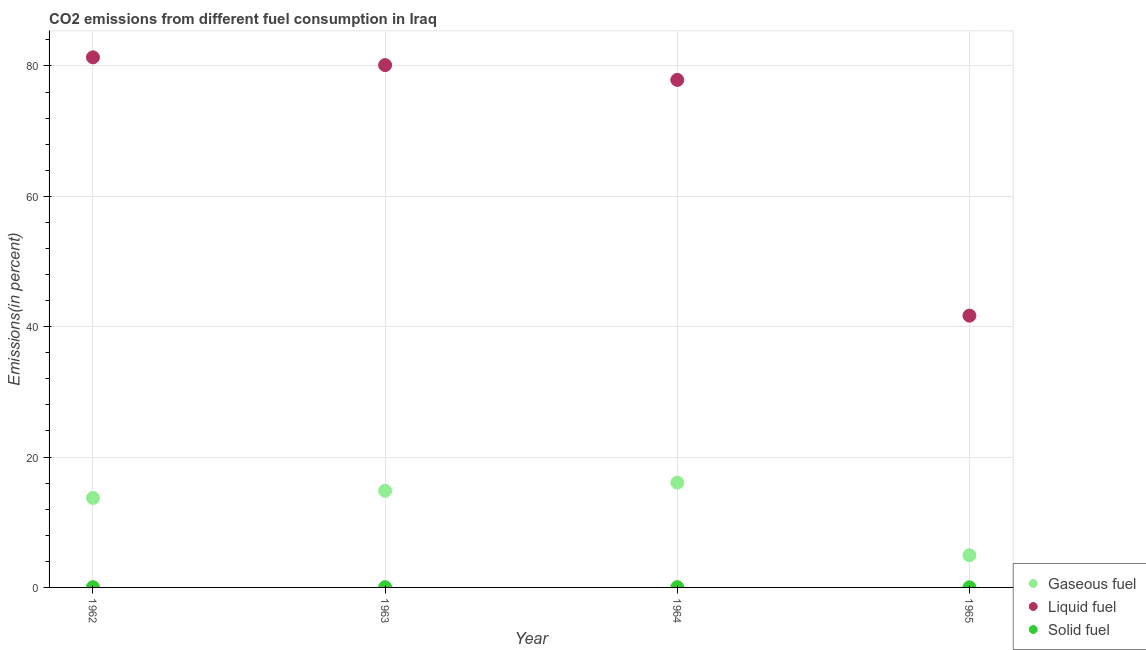How many different coloured dotlines are there?
Offer a very short reply. 3. Is the number of dotlines equal to the number of legend labels?
Make the answer very short. Yes. What is the percentage of solid fuel emission in 1962?
Make the answer very short. 0.04. Across all years, what is the maximum percentage of gaseous fuel emission?
Give a very brief answer. 16.08. Across all years, what is the minimum percentage of gaseous fuel emission?
Give a very brief answer. 4.94. In which year was the percentage of gaseous fuel emission maximum?
Your response must be concise. 1964. In which year was the percentage of liquid fuel emission minimum?
Offer a terse response. 1965. What is the total percentage of gaseous fuel emission in the graph?
Keep it short and to the point. 49.57. What is the difference between the percentage of liquid fuel emission in 1962 and that in 1965?
Your answer should be very brief. 39.63. What is the difference between the percentage of liquid fuel emission in 1963 and the percentage of gaseous fuel emission in 1962?
Give a very brief answer. 66.41. What is the average percentage of gaseous fuel emission per year?
Your answer should be very brief. 12.39. In the year 1964, what is the difference between the percentage of solid fuel emission and percentage of gaseous fuel emission?
Your answer should be very brief. -16.04. In how many years, is the percentage of solid fuel emission greater than 60 %?
Make the answer very short. 0. What is the ratio of the percentage of solid fuel emission in 1962 to that in 1963?
Provide a succinct answer. 1.04. Is the difference between the percentage of gaseous fuel emission in 1962 and 1963 greater than the difference between the percentage of solid fuel emission in 1962 and 1963?
Your answer should be compact. No. What is the difference between the highest and the second highest percentage of liquid fuel emission?
Give a very brief answer. 1.19. What is the difference between the highest and the lowest percentage of liquid fuel emission?
Offer a very short reply. 39.63. In how many years, is the percentage of gaseous fuel emission greater than the average percentage of gaseous fuel emission taken over all years?
Make the answer very short. 3. Is it the case that in every year, the sum of the percentage of gaseous fuel emission and percentage of liquid fuel emission is greater than the percentage of solid fuel emission?
Make the answer very short. Yes. Does the percentage of gaseous fuel emission monotonically increase over the years?
Offer a terse response. No. Is the percentage of solid fuel emission strictly greater than the percentage of liquid fuel emission over the years?
Make the answer very short. No. How many dotlines are there?
Provide a short and direct response. 3. How many years are there in the graph?
Make the answer very short. 4. Does the graph contain grids?
Offer a very short reply. Yes. Where does the legend appear in the graph?
Make the answer very short. Bottom right. How many legend labels are there?
Keep it short and to the point. 3. How are the legend labels stacked?
Offer a very short reply. Vertical. What is the title of the graph?
Provide a short and direct response. CO2 emissions from different fuel consumption in Iraq. Does "Transport equipments" appear as one of the legend labels in the graph?
Provide a short and direct response. No. What is the label or title of the X-axis?
Offer a terse response. Year. What is the label or title of the Y-axis?
Keep it short and to the point. Emissions(in percent). What is the Emissions(in percent) in Gaseous fuel in 1962?
Keep it short and to the point. 13.72. What is the Emissions(in percent) in Liquid fuel in 1962?
Your answer should be very brief. 81.32. What is the Emissions(in percent) in Solid fuel in 1962?
Make the answer very short. 0.04. What is the Emissions(in percent) of Gaseous fuel in 1963?
Offer a terse response. 14.83. What is the Emissions(in percent) of Liquid fuel in 1963?
Your answer should be very brief. 80.13. What is the Emissions(in percent) of Solid fuel in 1963?
Provide a succinct answer. 0.04. What is the Emissions(in percent) in Gaseous fuel in 1964?
Make the answer very short. 16.08. What is the Emissions(in percent) of Liquid fuel in 1964?
Offer a terse response. 77.86. What is the Emissions(in percent) in Solid fuel in 1964?
Your answer should be very brief. 0.04. What is the Emissions(in percent) in Gaseous fuel in 1965?
Your answer should be very brief. 4.94. What is the Emissions(in percent) in Liquid fuel in 1965?
Offer a very short reply. 41.69. What is the Emissions(in percent) of Solid fuel in 1965?
Your answer should be compact. 0.02. Across all years, what is the maximum Emissions(in percent) of Gaseous fuel?
Provide a short and direct response. 16.08. Across all years, what is the maximum Emissions(in percent) in Liquid fuel?
Your response must be concise. 81.32. Across all years, what is the maximum Emissions(in percent) in Solid fuel?
Keep it short and to the point. 0.04. Across all years, what is the minimum Emissions(in percent) of Gaseous fuel?
Make the answer very short. 4.94. Across all years, what is the minimum Emissions(in percent) in Liquid fuel?
Your answer should be very brief. 41.69. Across all years, what is the minimum Emissions(in percent) of Solid fuel?
Offer a terse response. 0.02. What is the total Emissions(in percent) of Gaseous fuel in the graph?
Make the answer very short. 49.57. What is the total Emissions(in percent) of Liquid fuel in the graph?
Offer a very short reply. 281.01. What is the total Emissions(in percent) of Solid fuel in the graph?
Your answer should be compact. 0.14. What is the difference between the Emissions(in percent) of Gaseous fuel in 1962 and that in 1963?
Make the answer very short. -1.11. What is the difference between the Emissions(in percent) of Liquid fuel in 1962 and that in 1963?
Provide a short and direct response. 1.19. What is the difference between the Emissions(in percent) in Solid fuel in 1962 and that in 1963?
Provide a short and direct response. 0. What is the difference between the Emissions(in percent) of Gaseous fuel in 1962 and that in 1964?
Give a very brief answer. -2.36. What is the difference between the Emissions(in percent) in Liquid fuel in 1962 and that in 1964?
Make the answer very short. 3.46. What is the difference between the Emissions(in percent) of Gaseous fuel in 1962 and that in 1965?
Your answer should be compact. 8.79. What is the difference between the Emissions(in percent) of Liquid fuel in 1962 and that in 1965?
Keep it short and to the point. 39.63. What is the difference between the Emissions(in percent) of Solid fuel in 1962 and that in 1965?
Give a very brief answer. 0.02. What is the difference between the Emissions(in percent) in Gaseous fuel in 1963 and that in 1964?
Your response must be concise. -1.25. What is the difference between the Emissions(in percent) of Liquid fuel in 1963 and that in 1964?
Make the answer very short. 2.27. What is the difference between the Emissions(in percent) in Solid fuel in 1963 and that in 1964?
Offer a terse response. -0. What is the difference between the Emissions(in percent) of Gaseous fuel in 1963 and that in 1965?
Make the answer very short. 9.9. What is the difference between the Emissions(in percent) of Liquid fuel in 1963 and that in 1965?
Make the answer very short. 38.44. What is the difference between the Emissions(in percent) of Solid fuel in 1963 and that in 1965?
Your response must be concise. 0.02. What is the difference between the Emissions(in percent) in Gaseous fuel in 1964 and that in 1965?
Offer a very short reply. 11.14. What is the difference between the Emissions(in percent) of Liquid fuel in 1964 and that in 1965?
Offer a terse response. 36.16. What is the difference between the Emissions(in percent) in Solid fuel in 1964 and that in 1965?
Provide a short and direct response. 0.02. What is the difference between the Emissions(in percent) in Gaseous fuel in 1962 and the Emissions(in percent) in Liquid fuel in 1963?
Your response must be concise. -66.41. What is the difference between the Emissions(in percent) of Gaseous fuel in 1962 and the Emissions(in percent) of Solid fuel in 1963?
Your answer should be very brief. 13.68. What is the difference between the Emissions(in percent) of Liquid fuel in 1962 and the Emissions(in percent) of Solid fuel in 1963?
Make the answer very short. 81.28. What is the difference between the Emissions(in percent) of Gaseous fuel in 1962 and the Emissions(in percent) of Liquid fuel in 1964?
Your answer should be very brief. -64.14. What is the difference between the Emissions(in percent) in Gaseous fuel in 1962 and the Emissions(in percent) in Solid fuel in 1964?
Keep it short and to the point. 13.68. What is the difference between the Emissions(in percent) in Liquid fuel in 1962 and the Emissions(in percent) in Solid fuel in 1964?
Provide a short and direct response. 81.28. What is the difference between the Emissions(in percent) in Gaseous fuel in 1962 and the Emissions(in percent) in Liquid fuel in 1965?
Your answer should be very brief. -27.97. What is the difference between the Emissions(in percent) of Gaseous fuel in 1962 and the Emissions(in percent) of Solid fuel in 1965?
Your answer should be compact. 13.7. What is the difference between the Emissions(in percent) in Liquid fuel in 1962 and the Emissions(in percent) in Solid fuel in 1965?
Keep it short and to the point. 81.3. What is the difference between the Emissions(in percent) in Gaseous fuel in 1963 and the Emissions(in percent) in Liquid fuel in 1964?
Offer a very short reply. -63.03. What is the difference between the Emissions(in percent) of Gaseous fuel in 1963 and the Emissions(in percent) of Solid fuel in 1964?
Your response must be concise. 14.79. What is the difference between the Emissions(in percent) in Liquid fuel in 1963 and the Emissions(in percent) in Solid fuel in 1964?
Your response must be concise. 80.09. What is the difference between the Emissions(in percent) of Gaseous fuel in 1963 and the Emissions(in percent) of Liquid fuel in 1965?
Give a very brief answer. -26.86. What is the difference between the Emissions(in percent) of Gaseous fuel in 1963 and the Emissions(in percent) of Solid fuel in 1965?
Give a very brief answer. 14.81. What is the difference between the Emissions(in percent) in Liquid fuel in 1963 and the Emissions(in percent) in Solid fuel in 1965?
Your answer should be very brief. 80.11. What is the difference between the Emissions(in percent) of Gaseous fuel in 1964 and the Emissions(in percent) of Liquid fuel in 1965?
Provide a short and direct response. -25.61. What is the difference between the Emissions(in percent) in Gaseous fuel in 1964 and the Emissions(in percent) in Solid fuel in 1965?
Provide a short and direct response. 16.06. What is the difference between the Emissions(in percent) in Liquid fuel in 1964 and the Emissions(in percent) in Solid fuel in 1965?
Offer a terse response. 77.84. What is the average Emissions(in percent) in Gaseous fuel per year?
Ensure brevity in your answer.  12.39. What is the average Emissions(in percent) in Liquid fuel per year?
Your response must be concise. 70.25. What is the average Emissions(in percent) in Solid fuel per year?
Offer a terse response. 0.03. In the year 1962, what is the difference between the Emissions(in percent) in Gaseous fuel and Emissions(in percent) in Liquid fuel?
Your answer should be very brief. -67.6. In the year 1962, what is the difference between the Emissions(in percent) in Gaseous fuel and Emissions(in percent) in Solid fuel?
Give a very brief answer. 13.68. In the year 1962, what is the difference between the Emissions(in percent) in Liquid fuel and Emissions(in percent) in Solid fuel?
Keep it short and to the point. 81.28. In the year 1963, what is the difference between the Emissions(in percent) of Gaseous fuel and Emissions(in percent) of Liquid fuel?
Ensure brevity in your answer.  -65.3. In the year 1963, what is the difference between the Emissions(in percent) in Gaseous fuel and Emissions(in percent) in Solid fuel?
Give a very brief answer. 14.79. In the year 1963, what is the difference between the Emissions(in percent) of Liquid fuel and Emissions(in percent) of Solid fuel?
Your answer should be compact. 80.09. In the year 1964, what is the difference between the Emissions(in percent) of Gaseous fuel and Emissions(in percent) of Liquid fuel?
Ensure brevity in your answer.  -61.78. In the year 1964, what is the difference between the Emissions(in percent) of Gaseous fuel and Emissions(in percent) of Solid fuel?
Provide a short and direct response. 16.04. In the year 1964, what is the difference between the Emissions(in percent) in Liquid fuel and Emissions(in percent) in Solid fuel?
Your answer should be compact. 77.82. In the year 1965, what is the difference between the Emissions(in percent) in Gaseous fuel and Emissions(in percent) in Liquid fuel?
Provide a short and direct response. -36.76. In the year 1965, what is the difference between the Emissions(in percent) of Gaseous fuel and Emissions(in percent) of Solid fuel?
Offer a very short reply. 4.92. In the year 1965, what is the difference between the Emissions(in percent) in Liquid fuel and Emissions(in percent) in Solid fuel?
Ensure brevity in your answer.  41.67. What is the ratio of the Emissions(in percent) of Gaseous fuel in 1962 to that in 1963?
Offer a very short reply. 0.93. What is the ratio of the Emissions(in percent) of Liquid fuel in 1962 to that in 1963?
Keep it short and to the point. 1.01. What is the ratio of the Emissions(in percent) of Solid fuel in 1962 to that in 1963?
Give a very brief answer. 1.04. What is the ratio of the Emissions(in percent) in Gaseous fuel in 1962 to that in 1964?
Make the answer very short. 0.85. What is the ratio of the Emissions(in percent) of Liquid fuel in 1962 to that in 1964?
Provide a succinct answer. 1.04. What is the ratio of the Emissions(in percent) of Solid fuel in 1962 to that in 1964?
Keep it short and to the point. 1. What is the ratio of the Emissions(in percent) in Gaseous fuel in 1962 to that in 1965?
Provide a short and direct response. 2.78. What is the ratio of the Emissions(in percent) of Liquid fuel in 1962 to that in 1965?
Offer a very short reply. 1.95. What is the ratio of the Emissions(in percent) of Solid fuel in 1962 to that in 1965?
Keep it short and to the point. 2.14. What is the ratio of the Emissions(in percent) of Gaseous fuel in 1963 to that in 1964?
Your answer should be very brief. 0.92. What is the ratio of the Emissions(in percent) in Liquid fuel in 1963 to that in 1964?
Provide a succinct answer. 1.03. What is the ratio of the Emissions(in percent) of Gaseous fuel in 1963 to that in 1965?
Provide a short and direct response. 3. What is the ratio of the Emissions(in percent) of Liquid fuel in 1963 to that in 1965?
Ensure brevity in your answer.  1.92. What is the ratio of the Emissions(in percent) in Solid fuel in 1963 to that in 1965?
Your answer should be very brief. 2.06. What is the ratio of the Emissions(in percent) of Gaseous fuel in 1964 to that in 1965?
Your response must be concise. 3.26. What is the ratio of the Emissions(in percent) of Liquid fuel in 1964 to that in 1965?
Your answer should be very brief. 1.87. What is the ratio of the Emissions(in percent) of Solid fuel in 1964 to that in 1965?
Your response must be concise. 2.13. What is the difference between the highest and the second highest Emissions(in percent) in Gaseous fuel?
Make the answer very short. 1.25. What is the difference between the highest and the second highest Emissions(in percent) in Liquid fuel?
Keep it short and to the point. 1.19. What is the difference between the highest and the lowest Emissions(in percent) of Gaseous fuel?
Your response must be concise. 11.14. What is the difference between the highest and the lowest Emissions(in percent) of Liquid fuel?
Your answer should be very brief. 39.63. What is the difference between the highest and the lowest Emissions(in percent) in Solid fuel?
Give a very brief answer. 0.02. 